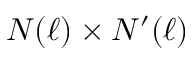Convert formula to latex. <formula><loc_0><loc_0><loc_500><loc_500>N ( \ell ) \times N ^ { \prime } ( \ell )</formula> 